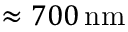<formula> <loc_0><loc_0><loc_500><loc_500>\approx 7 0 0 \, n m</formula> 